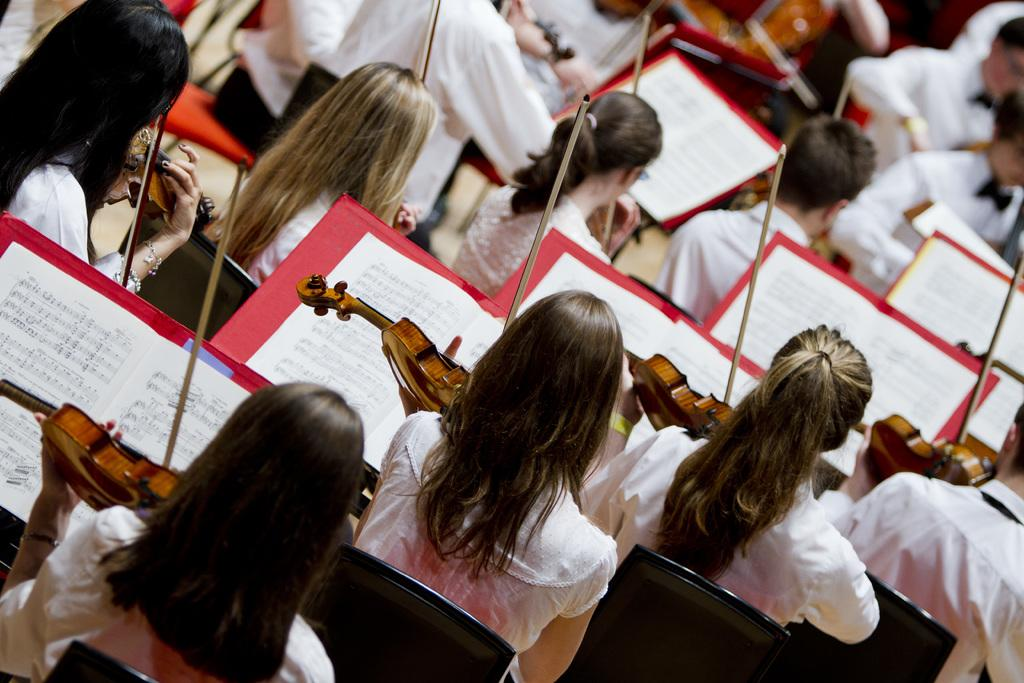What are the persons in the image doing? The persons in the image are sitting on chairs. What objects can be seen in the image besides the chairs? There are books and a violin visible in the image. How many brothers are playing with the sticks in the image? There are no sticks or brothers present in the image. What type of vessel is being used to transport the violin in the image? There is no vessel present in the image, and the violin is not being transported. 